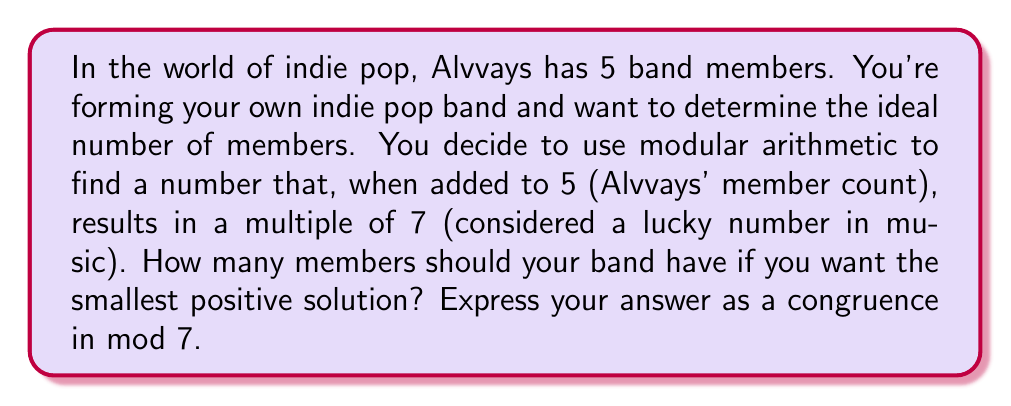Teach me how to tackle this problem. Let's approach this step-by-step using modular arithmetic:

1) Let $x$ be the number of members in your new band.

2) We want $(x + 5)$ to be a multiple of 7. In modular arithmetic, this is equivalent to:

   $x + 5 \equiv 0 \pmod{7}$

3) To solve for $x$, we subtract 5 from both sides:

   $x \equiv -5 \pmod{7}$

4) In modular arithmetic, we typically express the result using the smallest non-negative residue. To find this, we can add 7 to -5 until we get a positive number less than 7:

   $-5 + 7 = 2$

5) Therefore, the smallest positive solution is:

   $x \equiv 2 \pmod{7}$

This means that your band should have 2 members to satisfy the condition.

Note: In the context of Alvvays, a 2-member indie pop band could be an interesting minimalist approach, focusing perhaps on vocals and guitar or keyboard, which are often prominent in Alvvays' music.
Answer: $x \equiv 2 \pmod{7}$ 